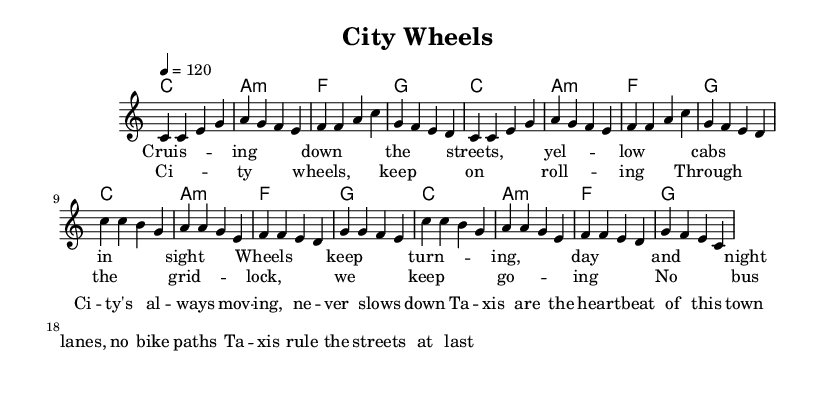What is the key signature of this music? The key signature is C major, which has no sharps or flats.
Answer: C major What is the time signature of this music? The time signature is noted as 4/4, meaning there are four beats per measure.
Answer: 4/4 What is the tempo marking for this piece? The tempo marking indicates a speed of 120 beats per minute, which is set in the tempo directive.
Answer: 120 How many measures are in the verse section? The verse section consists of 8 measures as can be counted in the melody section.
Answer: 8 What is the relationship between the verse and chorus harmonies? The verse and chorus both utilize the same chord progression: C, A minor, F, and G, which creates a cohesive sound throughout the piece.
Answer: Same chord progression How many lines are in the chorus lyrics? The chorus has four lines as indicated in its lyrical structure.
Answer: 4 What type of musical piece is this song categorized as? This song falls under the category of pop music, specifically due to its catchy lyrics and urban theme.
Answer: Pop 